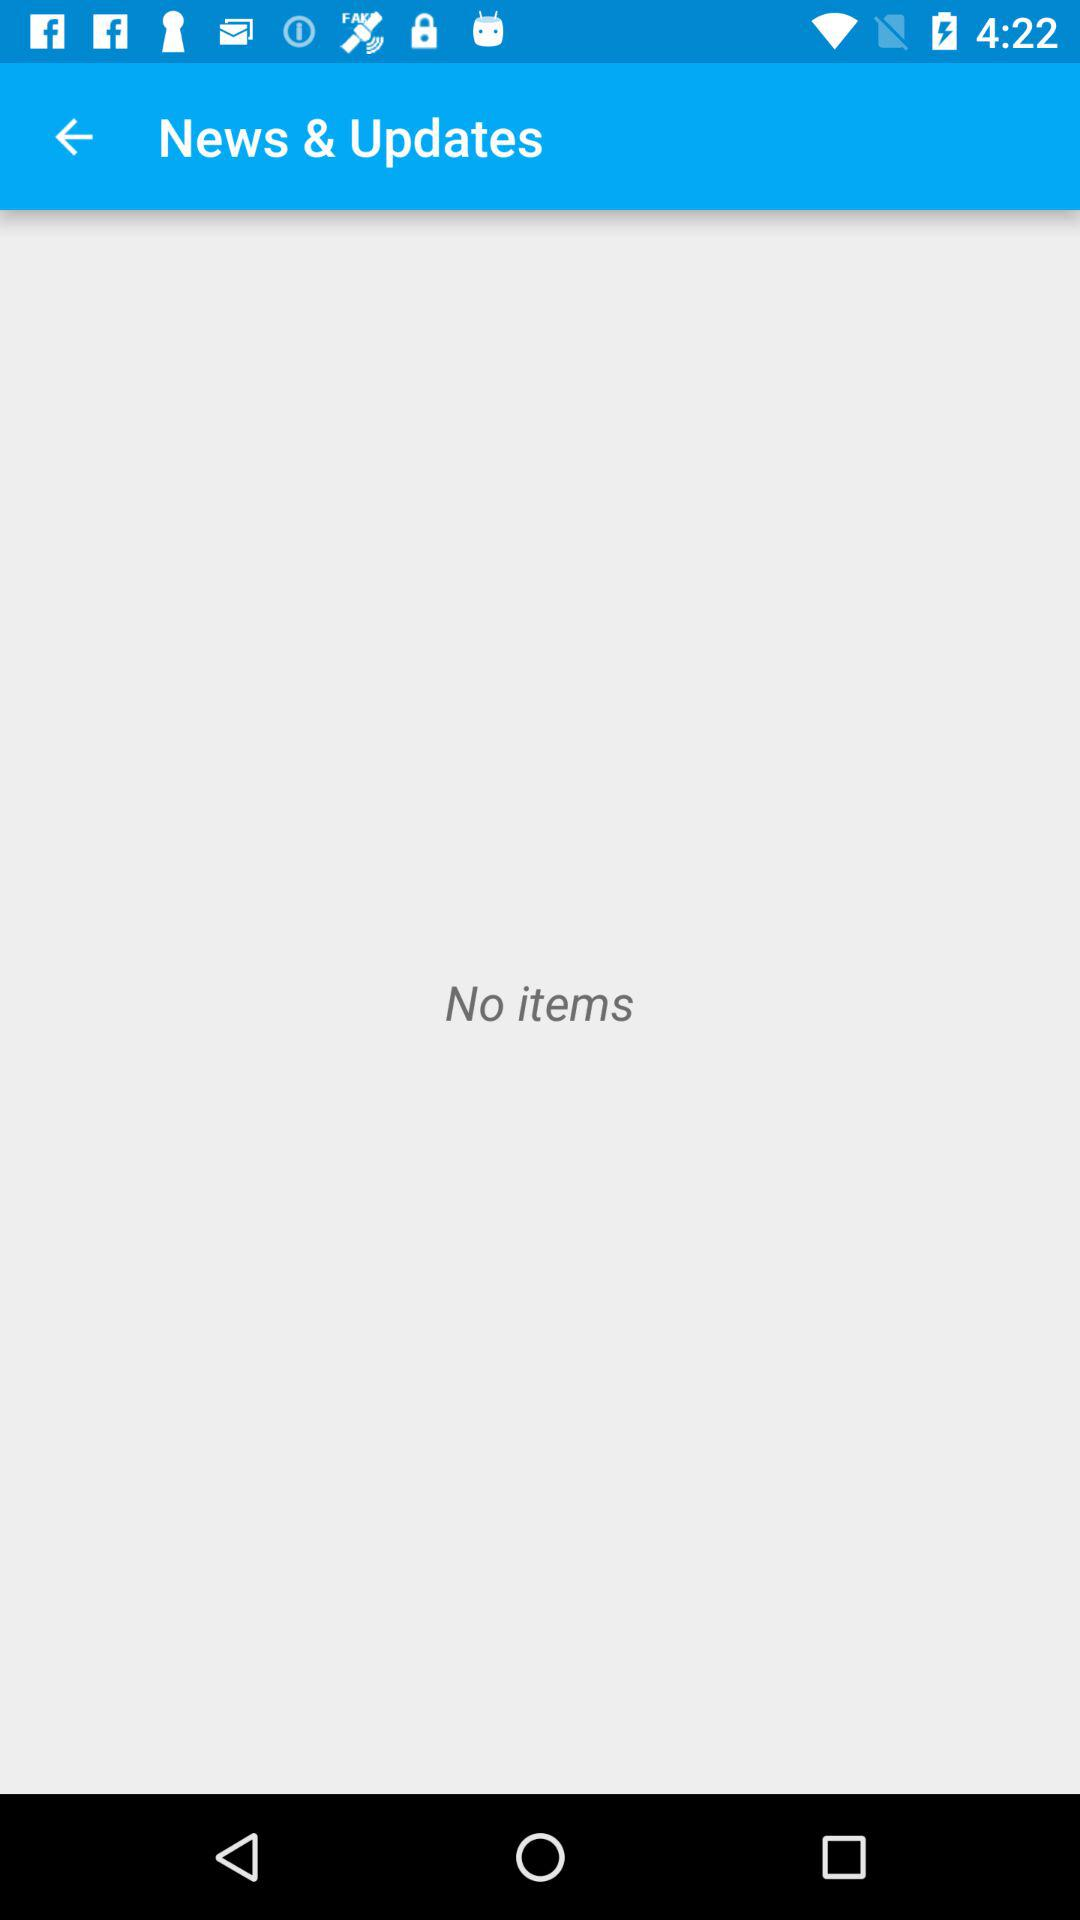Are there any items? There are no items. 